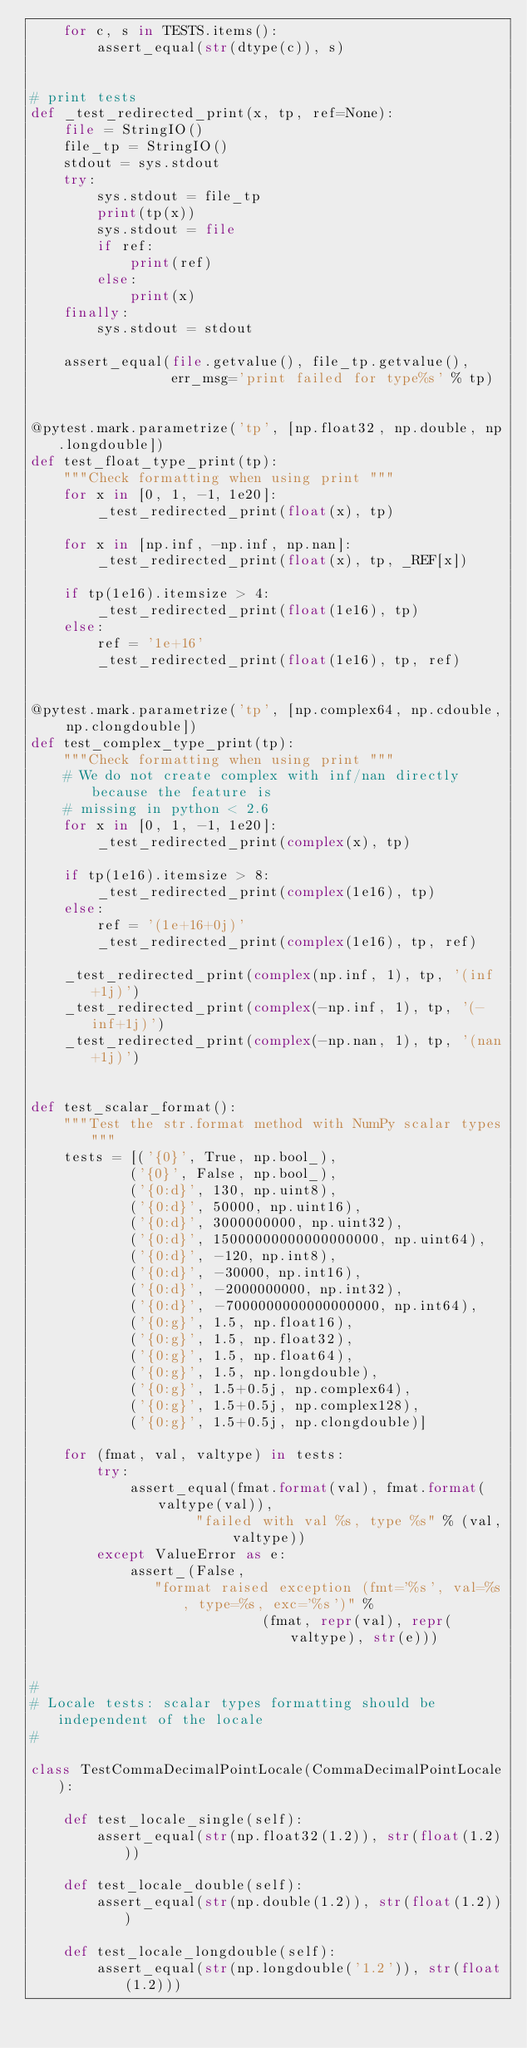<code> <loc_0><loc_0><loc_500><loc_500><_Python_>    for c, s in TESTS.items():
        assert_equal(str(dtype(c)), s)


# print tests
def _test_redirected_print(x, tp, ref=None):
    file = StringIO()
    file_tp = StringIO()
    stdout = sys.stdout
    try:
        sys.stdout = file_tp
        print(tp(x))
        sys.stdout = file
        if ref:
            print(ref)
        else:
            print(x)
    finally:
        sys.stdout = stdout

    assert_equal(file.getvalue(), file_tp.getvalue(),
                 err_msg='print failed for type%s' % tp)


@pytest.mark.parametrize('tp', [np.float32, np.double, np.longdouble])
def test_float_type_print(tp):
    """Check formatting when using print """
    for x in [0, 1, -1, 1e20]:
        _test_redirected_print(float(x), tp)

    for x in [np.inf, -np.inf, np.nan]:
        _test_redirected_print(float(x), tp, _REF[x])

    if tp(1e16).itemsize > 4:
        _test_redirected_print(float(1e16), tp)
    else:
        ref = '1e+16'
        _test_redirected_print(float(1e16), tp, ref)


@pytest.mark.parametrize('tp', [np.complex64, np.cdouble, np.clongdouble])
def test_complex_type_print(tp):
    """Check formatting when using print """
    # We do not create complex with inf/nan directly because the feature is
    # missing in python < 2.6
    for x in [0, 1, -1, 1e20]:
        _test_redirected_print(complex(x), tp)

    if tp(1e16).itemsize > 8:
        _test_redirected_print(complex(1e16), tp)
    else:
        ref = '(1e+16+0j)'
        _test_redirected_print(complex(1e16), tp, ref)

    _test_redirected_print(complex(np.inf, 1), tp, '(inf+1j)')
    _test_redirected_print(complex(-np.inf, 1), tp, '(-inf+1j)')
    _test_redirected_print(complex(-np.nan, 1), tp, '(nan+1j)')


def test_scalar_format():
    """Test the str.format method with NumPy scalar types"""
    tests = [('{0}', True, np.bool_),
            ('{0}', False, np.bool_),
            ('{0:d}', 130, np.uint8),
            ('{0:d}', 50000, np.uint16),
            ('{0:d}', 3000000000, np.uint32),
            ('{0:d}', 15000000000000000000, np.uint64),
            ('{0:d}', -120, np.int8),
            ('{0:d}', -30000, np.int16),
            ('{0:d}', -2000000000, np.int32),
            ('{0:d}', -7000000000000000000, np.int64),
            ('{0:g}', 1.5, np.float16),
            ('{0:g}', 1.5, np.float32),
            ('{0:g}', 1.5, np.float64),
            ('{0:g}', 1.5, np.longdouble),
            ('{0:g}', 1.5+0.5j, np.complex64),
            ('{0:g}', 1.5+0.5j, np.complex128),
            ('{0:g}', 1.5+0.5j, np.clongdouble)]

    for (fmat, val, valtype) in tests:
        try:
            assert_equal(fmat.format(val), fmat.format(valtype(val)),
                    "failed with val %s, type %s" % (val, valtype))
        except ValueError as e:
            assert_(False,
               "format raised exception (fmt='%s', val=%s, type=%s, exc='%s')" %
                            (fmat, repr(val), repr(valtype), str(e)))


#
# Locale tests: scalar types formatting should be independent of the locale
#

class TestCommaDecimalPointLocale(CommaDecimalPointLocale):

    def test_locale_single(self):
        assert_equal(str(np.float32(1.2)), str(float(1.2)))

    def test_locale_double(self):
        assert_equal(str(np.double(1.2)), str(float(1.2)))

    def test_locale_longdouble(self):
        assert_equal(str(np.longdouble('1.2')), str(float(1.2)))
</code> 